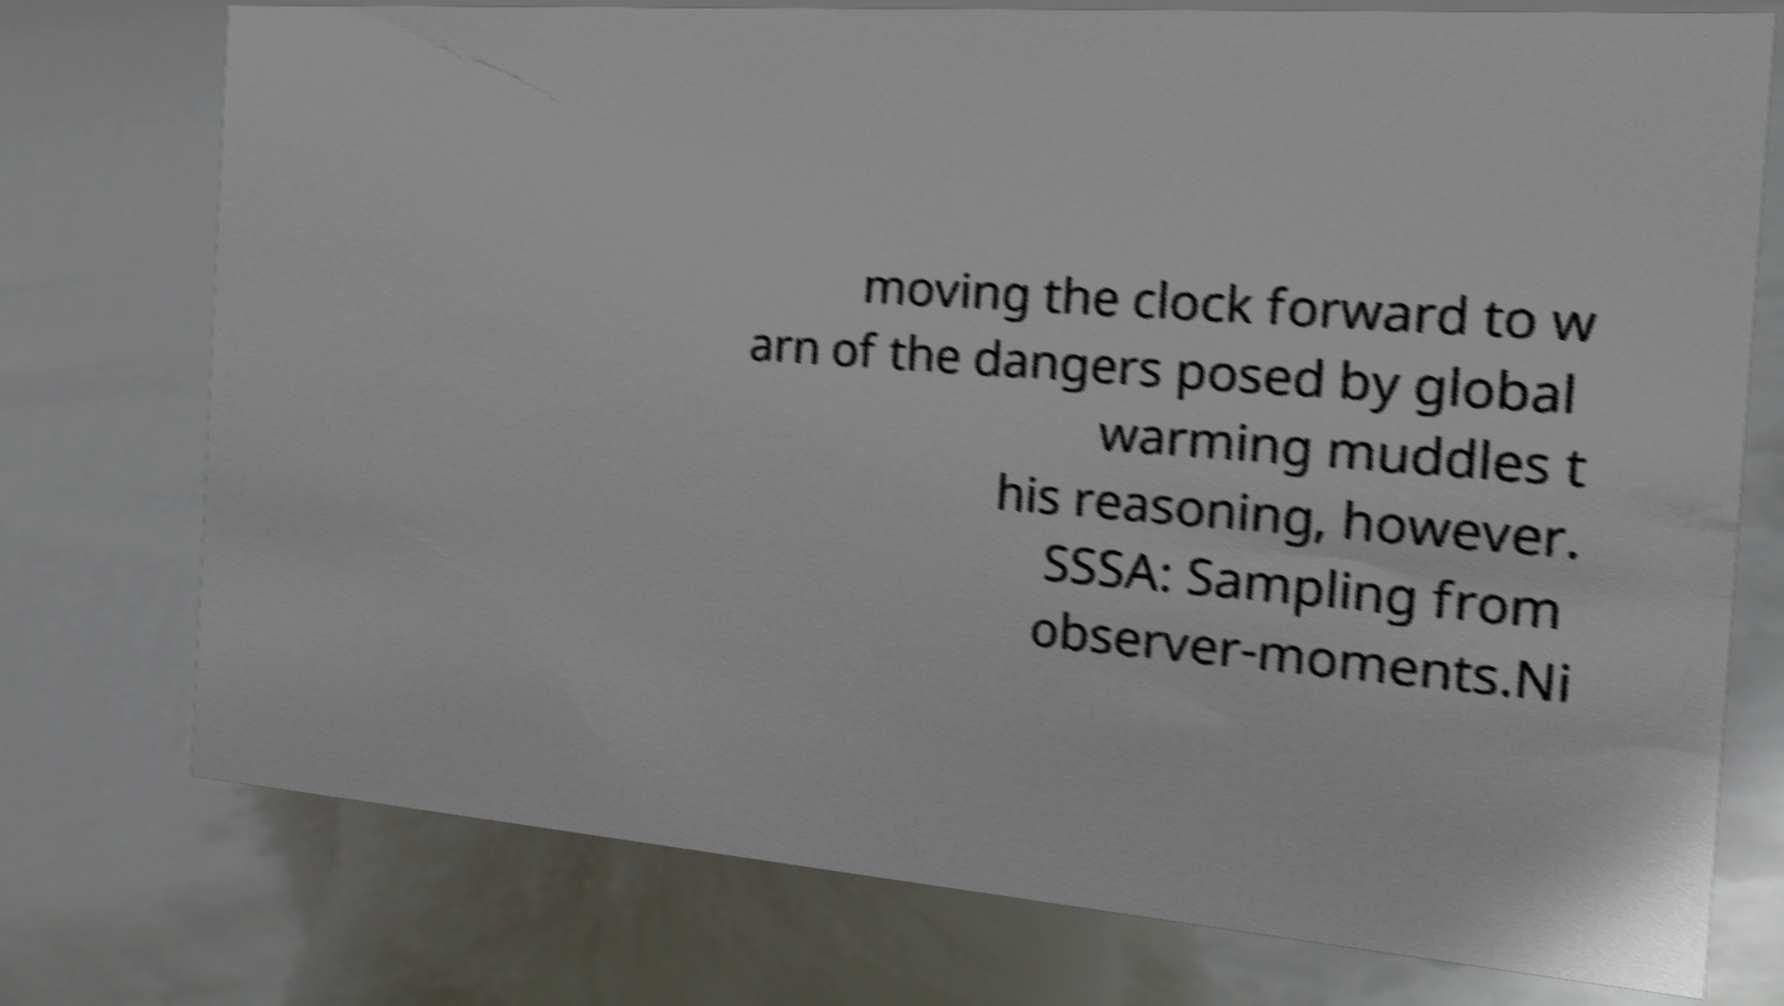What messages or text are displayed in this image? I need them in a readable, typed format. moving the clock forward to w arn of the dangers posed by global warming muddles t his reasoning, however. SSSA: Sampling from observer-moments.Ni 